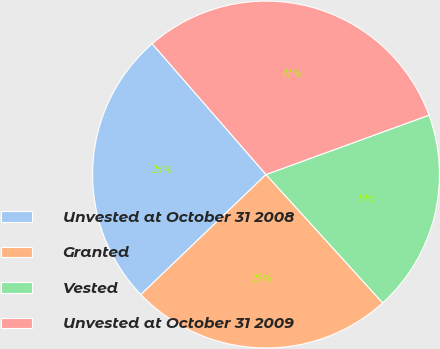Convert chart. <chart><loc_0><loc_0><loc_500><loc_500><pie_chart><fcel>Unvested at October 31 2008<fcel>Granted<fcel>Vested<fcel>Unvested at October 31 2009<nl><fcel>25.77%<fcel>24.57%<fcel>18.82%<fcel>30.84%<nl></chart> 